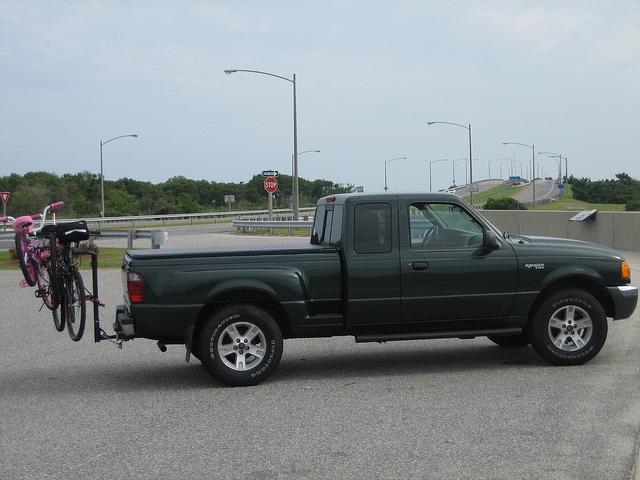What brand of truck is this?
Concise answer only. Ford. What type of vehicle is this?
Be succinct. Truck. Is this vehicle indoors or out?
Concise answer only. Out. What is on the very end of the truck?
Give a very brief answer. Bicycles. Is the street one-way?
Concise answer only. No. What color is this truck?
Concise answer only. Black. How many doors does the truck have?
Give a very brief answer. 2. 